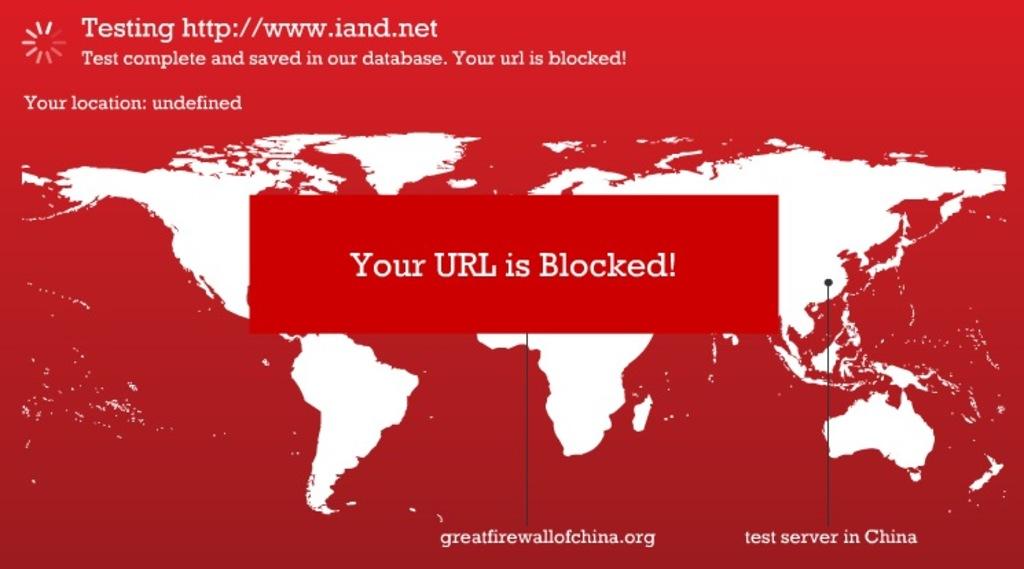What error message is this showing?
Provide a short and direct response. Your url is blocked. What is blocked?
Make the answer very short. Your url. 